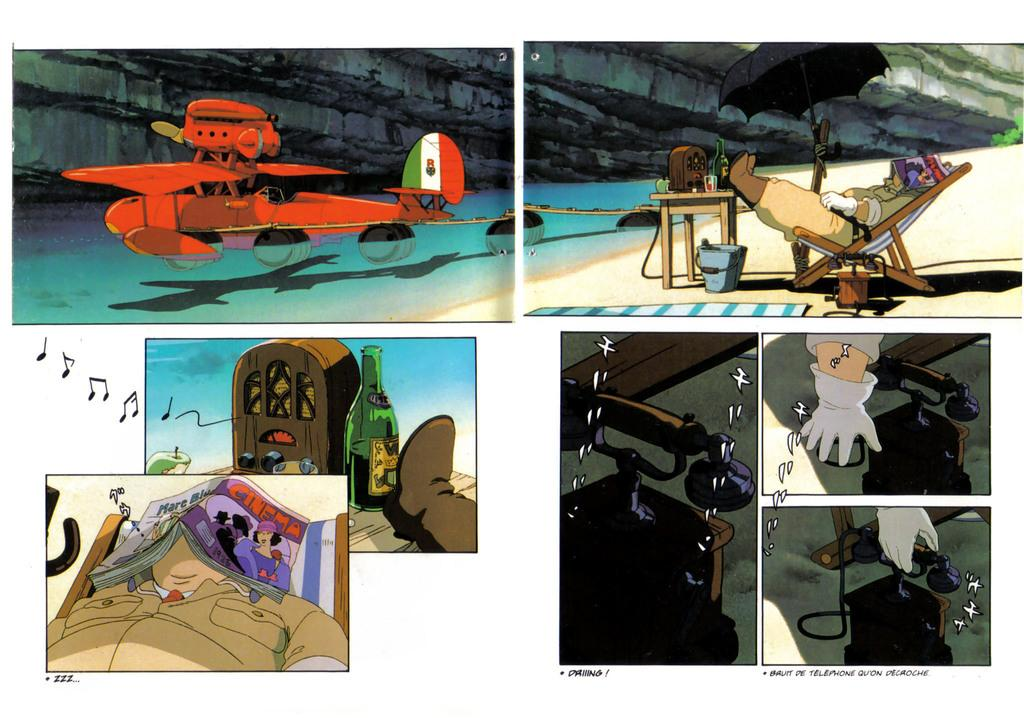<image>
Write a terse but informative summary of the picture. the word telephone is below a cartoon image of a person 